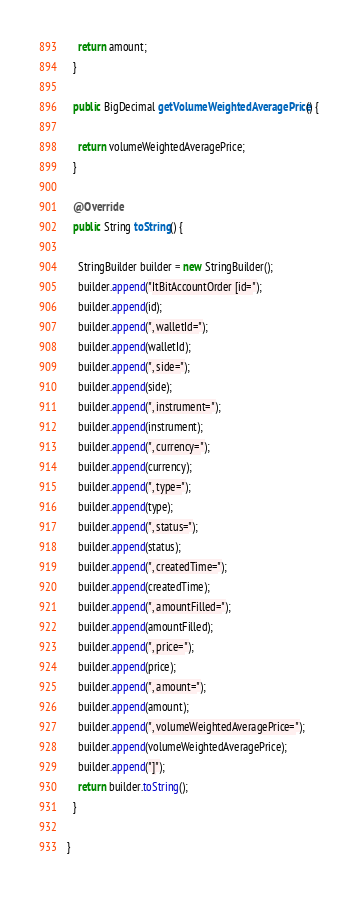Convert code to text. <code><loc_0><loc_0><loc_500><loc_500><_Java_>    return amount;
  }

  public BigDecimal getVolumeWeightedAveragePrice() {

    return volumeWeightedAveragePrice;
  }

  @Override
  public String toString() {

    StringBuilder builder = new StringBuilder();
    builder.append("ItBitAccountOrder [id=");
    builder.append(id);
    builder.append(", walletId=");
    builder.append(walletId);
    builder.append(", side=");
    builder.append(side);
    builder.append(", instrument=");
    builder.append(instrument);
    builder.append(", currency=");
    builder.append(currency);
    builder.append(", type=");
    builder.append(type);
    builder.append(", status=");
    builder.append(status);
    builder.append(", createdTime=");
    builder.append(createdTime);
    builder.append(", amountFilled=");
    builder.append(amountFilled);
    builder.append(", price=");
    builder.append(price);
    builder.append(", amount=");
    builder.append(amount);
    builder.append(", volumeWeightedAveragePrice=");
    builder.append(volumeWeightedAveragePrice);
    builder.append("]");
    return builder.toString();
  }

}
</code> 